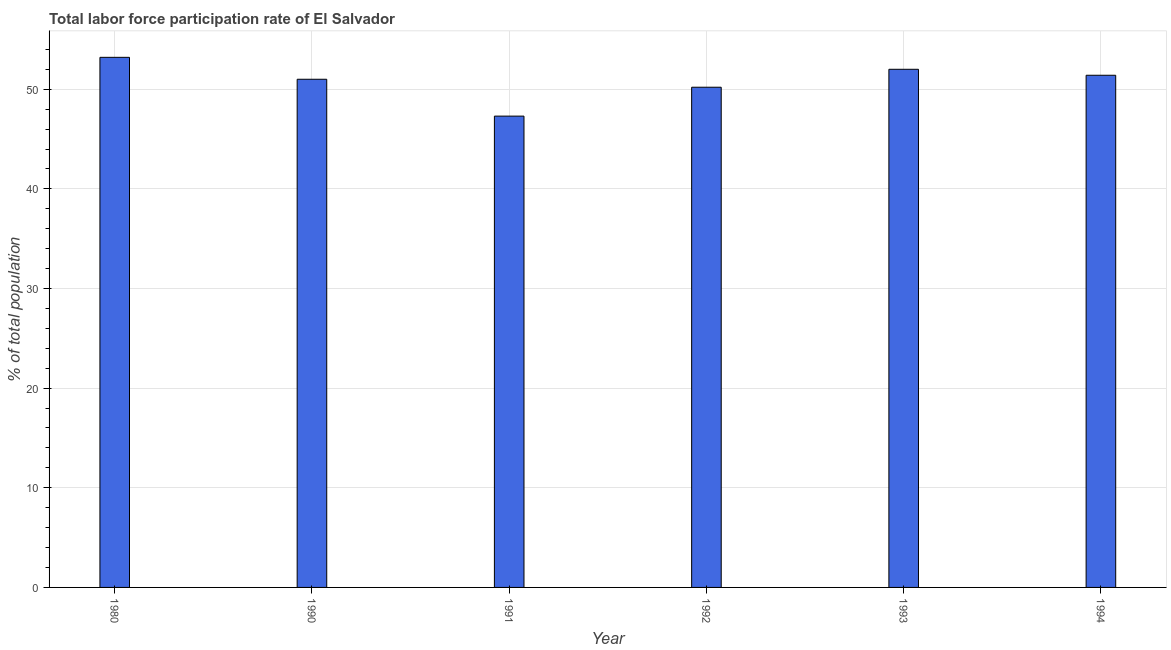Does the graph contain any zero values?
Keep it short and to the point. No. Does the graph contain grids?
Your answer should be very brief. Yes. What is the title of the graph?
Your answer should be compact. Total labor force participation rate of El Salvador. What is the label or title of the X-axis?
Ensure brevity in your answer.  Year. What is the label or title of the Y-axis?
Provide a succinct answer. % of total population. What is the total labor force participation rate in 1994?
Provide a succinct answer. 51.4. Across all years, what is the maximum total labor force participation rate?
Ensure brevity in your answer.  53.2. Across all years, what is the minimum total labor force participation rate?
Your response must be concise. 47.3. In which year was the total labor force participation rate maximum?
Keep it short and to the point. 1980. In which year was the total labor force participation rate minimum?
Provide a short and direct response. 1991. What is the sum of the total labor force participation rate?
Give a very brief answer. 305.1. What is the difference between the total labor force participation rate in 1991 and 1993?
Offer a terse response. -4.7. What is the average total labor force participation rate per year?
Your answer should be very brief. 50.85. What is the median total labor force participation rate?
Your answer should be very brief. 51.2. What is the difference between the highest and the second highest total labor force participation rate?
Your answer should be compact. 1.2. What is the difference between the highest and the lowest total labor force participation rate?
Your response must be concise. 5.9. How many bars are there?
Keep it short and to the point. 6. Are the values on the major ticks of Y-axis written in scientific E-notation?
Keep it short and to the point. No. What is the % of total population in 1980?
Make the answer very short. 53.2. What is the % of total population of 1991?
Offer a terse response. 47.3. What is the % of total population of 1992?
Your answer should be very brief. 50.2. What is the % of total population of 1994?
Give a very brief answer. 51.4. What is the difference between the % of total population in 1980 and 1990?
Offer a very short reply. 2.2. What is the difference between the % of total population in 1980 and 1991?
Keep it short and to the point. 5.9. What is the difference between the % of total population in 1980 and 1994?
Keep it short and to the point. 1.8. What is the difference between the % of total population in 1990 and 1991?
Offer a very short reply. 3.7. What is the difference between the % of total population in 1990 and 1992?
Provide a succinct answer. 0.8. What is the difference between the % of total population in 1990 and 1993?
Offer a very short reply. -1. What is the difference between the % of total population in 1990 and 1994?
Ensure brevity in your answer.  -0.4. What is the difference between the % of total population in 1991 and 1992?
Your answer should be very brief. -2.9. What is the difference between the % of total population in 1991 and 1993?
Provide a short and direct response. -4.7. What is the difference between the % of total population in 1991 and 1994?
Offer a very short reply. -4.1. What is the ratio of the % of total population in 1980 to that in 1990?
Keep it short and to the point. 1.04. What is the ratio of the % of total population in 1980 to that in 1991?
Your answer should be very brief. 1.12. What is the ratio of the % of total population in 1980 to that in 1992?
Offer a terse response. 1.06. What is the ratio of the % of total population in 1980 to that in 1993?
Give a very brief answer. 1.02. What is the ratio of the % of total population in 1980 to that in 1994?
Offer a very short reply. 1.03. What is the ratio of the % of total population in 1990 to that in 1991?
Make the answer very short. 1.08. What is the ratio of the % of total population in 1990 to that in 1992?
Offer a terse response. 1.02. What is the ratio of the % of total population in 1990 to that in 1994?
Make the answer very short. 0.99. What is the ratio of the % of total population in 1991 to that in 1992?
Offer a terse response. 0.94. What is the ratio of the % of total population in 1991 to that in 1993?
Your answer should be compact. 0.91. What is the ratio of the % of total population in 1992 to that in 1993?
Your response must be concise. 0.96. 